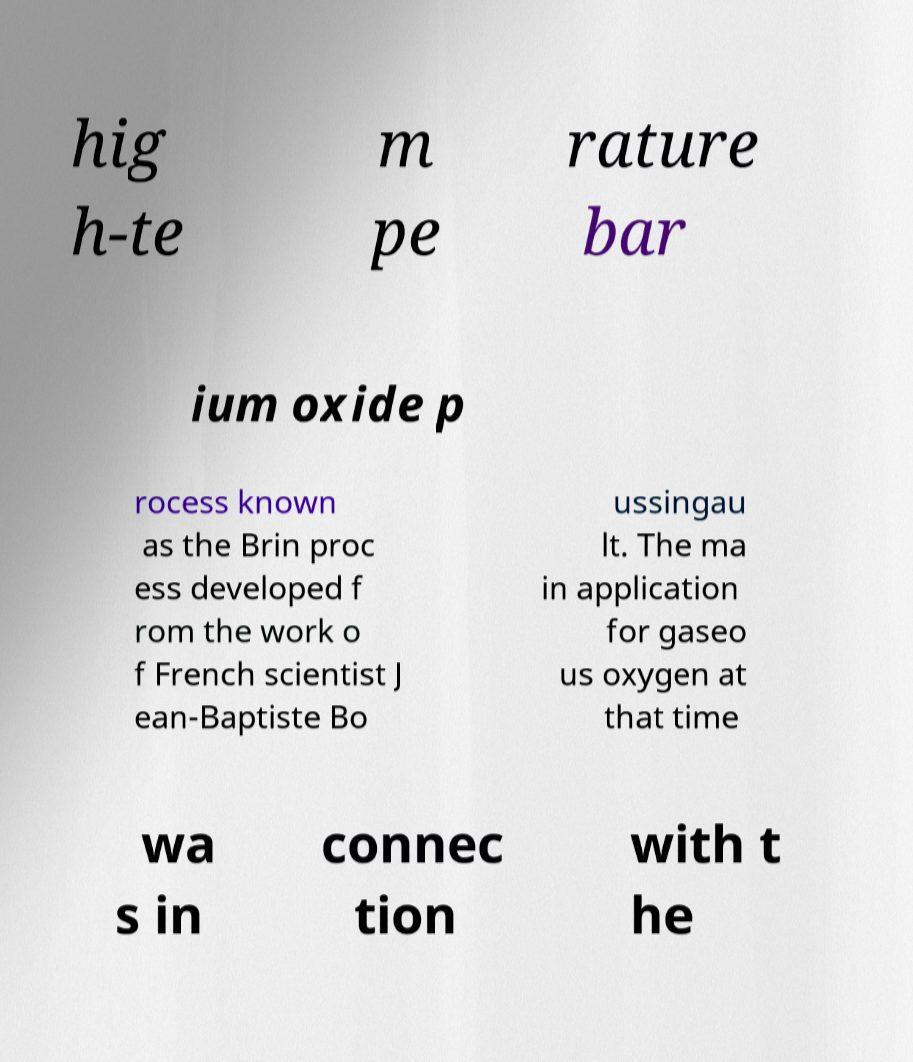I need the written content from this picture converted into text. Can you do that? hig h-te m pe rature bar ium oxide p rocess known as the Brin proc ess developed f rom the work o f French scientist J ean-Baptiste Bo ussingau lt. The ma in application for gaseo us oxygen at that time wa s in connec tion with t he 